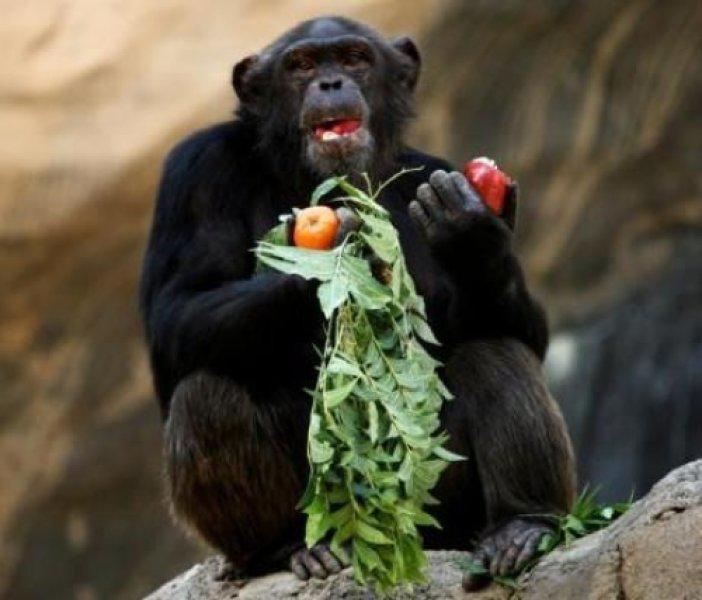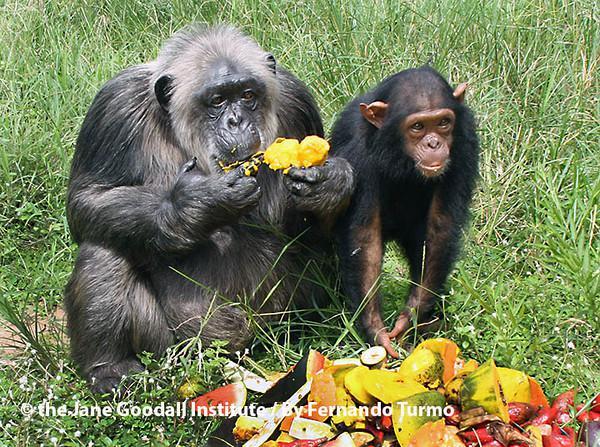The first image is the image on the left, the second image is the image on the right. For the images displayed, is the sentence "One of the monkeys is not eating." factually correct? Answer yes or no. Yes. The first image is the image on the left, the second image is the image on the right. Assess this claim about the two images: "At least one chimp has something to eat in each image, and no chimp is using cutlery to eat.". Correct or not? Answer yes or no. Yes. 